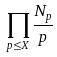<formula> <loc_0><loc_0><loc_500><loc_500>\prod _ { p \leq X } \frac { N _ { p } } { p }</formula> 